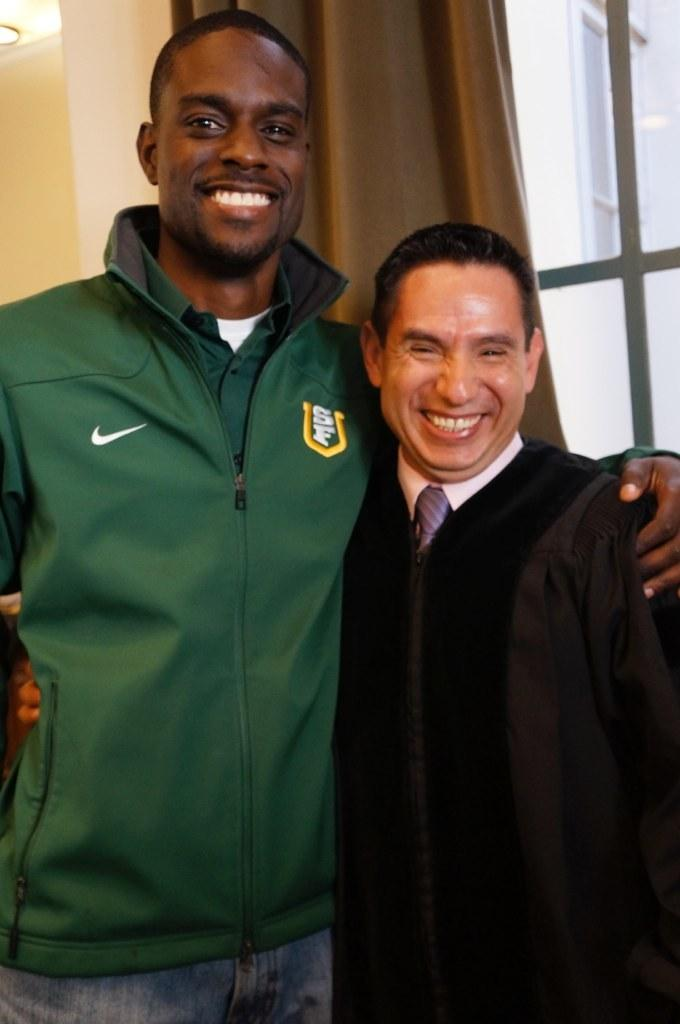How many people are in the image? There are two persons standing in the middle of the image. Can you describe the setting or context of the image? The image features two people standing together, but there is no specific context provided. What is visible in the background of the image? There is a curtain present in the background, likely associated with a window. What historical event is being commemorated by the two persons in the image? There is no indication of a historical event or commemoration in the image; it simply features two people standing together. 